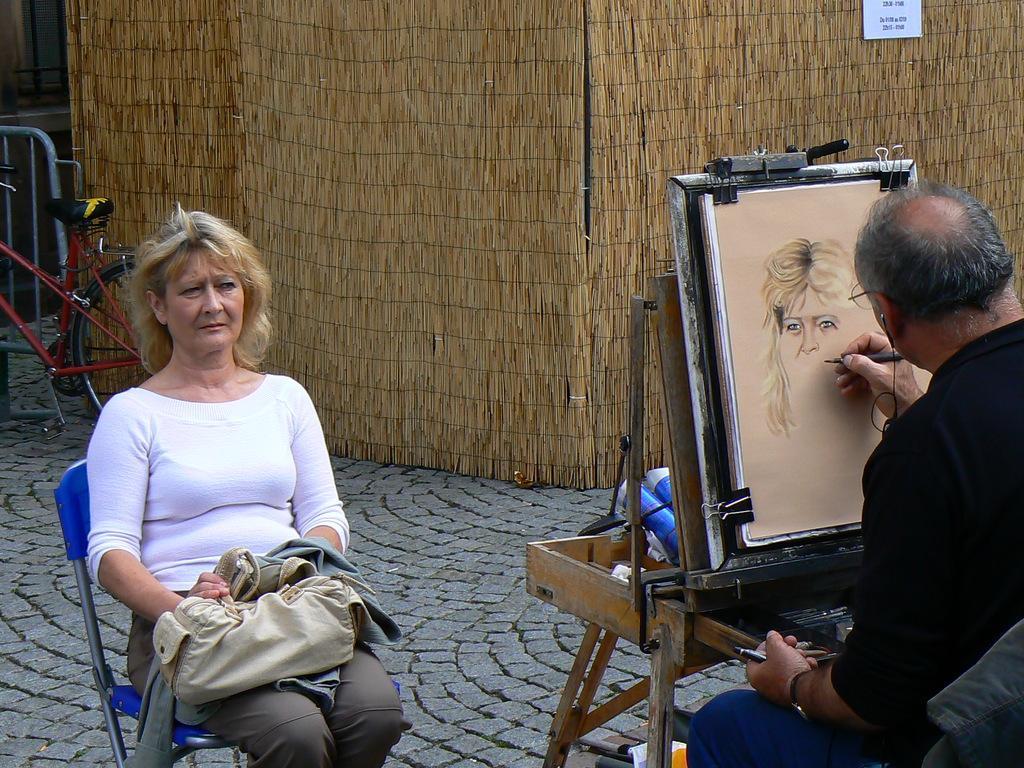How would you summarize this image in a sentence or two? In this image I see a woman, sitting on the chair and there is a man who is holding the pen and there is a table in front of him, on which there is a paper. In the background I see a cycle. 